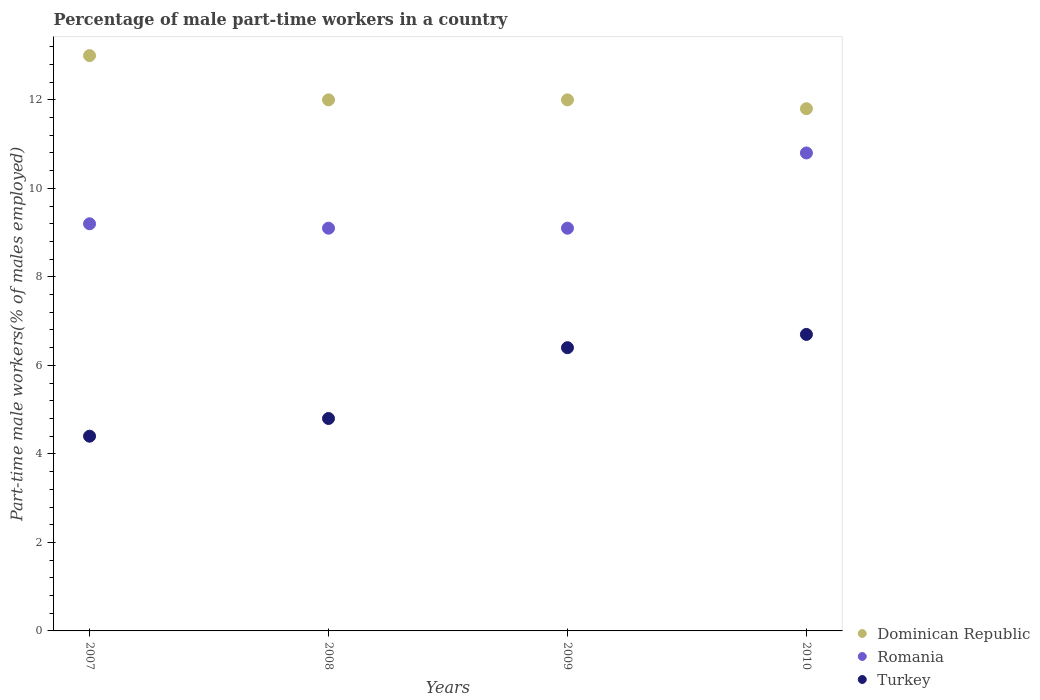How many different coloured dotlines are there?
Make the answer very short. 3. What is the percentage of male part-time workers in Dominican Republic in 2009?
Offer a terse response. 12. Across all years, what is the maximum percentage of male part-time workers in Romania?
Make the answer very short. 10.8. Across all years, what is the minimum percentage of male part-time workers in Romania?
Offer a terse response. 9.1. In which year was the percentage of male part-time workers in Romania maximum?
Make the answer very short. 2010. In which year was the percentage of male part-time workers in Romania minimum?
Ensure brevity in your answer.  2008. What is the total percentage of male part-time workers in Romania in the graph?
Provide a short and direct response. 38.2. What is the difference between the percentage of male part-time workers in Turkey in 2008 and that in 2010?
Your answer should be compact. -1.9. What is the difference between the percentage of male part-time workers in Romania in 2009 and the percentage of male part-time workers in Turkey in 2010?
Your answer should be compact. 2.4. What is the average percentage of male part-time workers in Turkey per year?
Provide a succinct answer. 5.58. In the year 2008, what is the difference between the percentage of male part-time workers in Turkey and percentage of male part-time workers in Dominican Republic?
Offer a very short reply. -7.2. In how many years, is the percentage of male part-time workers in Dominican Republic greater than 11.6 %?
Give a very brief answer. 4. What is the ratio of the percentage of male part-time workers in Dominican Republic in 2007 to that in 2010?
Provide a succinct answer. 1.1. What is the difference between the highest and the second highest percentage of male part-time workers in Romania?
Provide a short and direct response. 1.6. What is the difference between the highest and the lowest percentage of male part-time workers in Turkey?
Provide a succinct answer. 2.3. In how many years, is the percentage of male part-time workers in Romania greater than the average percentage of male part-time workers in Romania taken over all years?
Give a very brief answer. 1. Is the sum of the percentage of male part-time workers in Romania in 2009 and 2010 greater than the maximum percentage of male part-time workers in Dominican Republic across all years?
Keep it short and to the point. Yes. Is it the case that in every year, the sum of the percentage of male part-time workers in Dominican Republic and percentage of male part-time workers in Turkey  is greater than the percentage of male part-time workers in Romania?
Your response must be concise. Yes. Is the percentage of male part-time workers in Romania strictly greater than the percentage of male part-time workers in Turkey over the years?
Offer a terse response. Yes. How many dotlines are there?
Provide a succinct answer. 3. How many years are there in the graph?
Your response must be concise. 4. Where does the legend appear in the graph?
Your response must be concise. Bottom right. What is the title of the graph?
Your answer should be compact. Percentage of male part-time workers in a country. What is the label or title of the Y-axis?
Make the answer very short. Part-time male workers(% of males employed). What is the Part-time male workers(% of males employed) of Romania in 2007?
Provide a succinct answer. 9.2. What is the Part-time male workers(% of males employed) of Turkey in 2007?
Make the answer very short. 4.4. What is the Part-time male workers(% of males employed) in Dominican Republic in 2008?
Keep it short and to the point. 12. What is the Part-time male workers(% of males employed) in Romania in 2008?
Make the answer very short. 9.1. What is the Part-time male workers(% of males employed) of Turkey in 2008?
Your response must be concise. 4.8. What is the Part-time male workers(% of males employed) in Romania in 2009?
Offer a terse response. 9.1. What is the Part-time male workers(% of males employed) of Turkey in 2009?
Offer a terse response. 6.4. What is the Part-time male workers(% of males employed) of Dominican Republic in 2010?
Provide a succinct answer. 11.8. What is the Part-time male workers(% of males employed) in Romania in 2010?
Your answer should be very brief. 10.8. What is the Part-time male workers(% of males employed) in Turkey in 2010?
Offer a very short reply. 6.7. Across all years, what is the maximum Part-time male workers(% of males employed) in Romania?
Provide a succinct answer. 10.8. Across all years, what is the maximum Part-time male workers(% of males employed) of Turkey?
Your response must be concise. 6.7. Across all years, what is the minimum Part-time male workers(% of males employed) in Dominican Republic?
Your response must be concise. 11.8. Across all years, what is the minimum Part-time male workers(% of males employed) of Romania?
Provide a short and direct response. 9.1. Across all years, what is the minimum Part-time male workers(% of males employed) in Turkey?
Offer a very short reply. 4.4. What is the total Part-time male workers(% of males employed) in Dominican Republic in the graph?
Give a very brief answer. 48.8. What is the total Part-time male workers(% of males employed) in Romania in the graph?
Your answer should be compact. 38.2. What is the total Part-time male workers(% of males employed) in Turkey in the graph?
Your response must be concise. 22.3. What is the difference between the Part-time male workers(% of males employed) of Dominican Republic in 2007 and that in 2008?
Provide a short and direct response. 1. What is the difference between the Part-time male workers(% of males employed) of Romania in 2007 and that in 2009?
Keep it short and to the point. 0.1. What is the difference between the Part-time male workers(% of males employed) of Turkey in 2007 and that in 2009?
Your answer should be compact. -2. What is the difference between the Part-time male workers(% of males employed) of Romania in 2007 and that in 2010?
Provide a succinct answer. -1.6. What is the difference between the Part-time male workers(% of males employed) of Turkey in 2007 and that in 2010?
Make the answer very short. -2.3. What is the difference between the Part-time male workers(% of males employed) of Turkey in 2008 and that in 2009?
Offer a terse response. -1.6. What is the difference between the Part-time male workers(% of males employed) in Dominican Republic in 2007 and the Part-time male workers(% of males employed) in Romania in 2009?
Give a very brief answer. 3.9. What is the difference between the Part-time male workers(% of males employed) in Dominican Republic in 2007 and the Part-time male workers(% of males employed) in Turkey in 2009?
Your response must be concise. 6.6. What is the difference between the Part-time male workers(% of males employed) of Romania in 2007 and the Part-time male workers(% of males employed) of Turkey in 2009?
Provide a succinct answer. 2.8. What is the difference between the Part-time male workers(% of males employed) in Dominican Republic in 2007 and the Part-time male workers(% of males employed) in Romania in 2010?
Give a very brief answer. 2.2. What is the difference between the Part-time male workers(% of males employed) of Dominican Republic in 2007 and the Part-time male workers(% of males employed) of Turkey in 2010?
Your answer should be compact. 6.3. What is the difference between the Part-time male workers(% of males employed) of Romania in 2007 and the Part-time male workers(% of males employed) of Turkey in 2010?
Ensure brevity in your answer.  2.5. What is the difference between the Part-time male workers(% of males employed) of Dominican Republic in 2008 and the Part-time male workers(% of males employed) of Turkey in 2009?
Your answer should be compact. 5.6. What is the difference between the Part-time male workers(% of males employed) in Dominican Republic in 2008 and the Part-time male workers(% of males employed) in Romania in 2010?
Offer a terse response. 1.2. What is the difference between the Part-time male workers(% of males employed) of Dominican Republic in 2009 and the Part-time male workers(% of males employed) of Romania in 2010?
Provide a short and direct response. 1.2. What is the difference between the Part-time male workers(% of males employed) of Romania in 2009 and the Part-time male workers(% of males employed) of Turkey in 2010?
Your response must be concise. 2.4. What is the average Part-time male workers(% of males employed) in Romania per year?
Make the answer very short. 9.55. What is the average Part-time male workers(% of males employed) in Turkey per year?
Provide a short and direct response. 5.58. In the year 2007, what is the difference between the Part-time male workers(% of males employed) of Dominican Republic and Part-time male workers(% of males employed) of Romania?
Provide a short and direct response. 3.8. In the year 2007, what is the difference between the Part-time male workers(% of males employed) in Dominican Republic and Part-time male workers(% of males employed) in Turkey?
Ensure brevity in your answer.  8.6. In the year 2008, what is the difference between the Part-time male workers(% of males employed) in Dominican Republic and Part-time male workers(% of males employed) in Romania?
Offer a terse response. 2.9. In the year 2009, what is the difference between the Part-time male workers(% of males employed) in Dominican Republic and Part-time male workers(% of males employed) in Romania?
Ensure brevity in your answer.  2.9. In the year 2009, what is the difference between the Part-time male workers(% of males employed) in Dominican Republic and Part-time male workers(% of males employed) in Turkey?
Keep it short and to the point. 5.6. In the year 2010, what is the difference between the Part-time male workers(% of males employed) in Dominican Republic and Part-time male workers(% of males employed) in Turkey?
Offer a terse response. 5.1. What is the ratio of the Part-time male workers(% of males employed) in Dominican Republic in 2007 to that in 2008?
Give a very brief answer. 1.08. What is the ratio of the Part-time male workers(% of males employed) in Romania in 2007 to that in 2008?
Keep it short and to the point. 1.01. What is the ratio of the Part-time male workers(% of males employed) in Turkey in 2007 to that in 2008?
Give a very brief answer. 0.92. What is the ratio of the Part-time male workers(% of males employed) in Romania in 2007 to that in 2009?
Make the answer very short. 1.01. What is the ratio of the Part-time male workers(% of males employed) in Turkey in 2007 to that in 2009?
Keep it short and to the point. 0.69. What is the ratio of the Part-time male workers(% of males employed) of Dominican Republic in 2007 to that in 2010?
Provide a succinct answer. 1.1. What is the ratio of the Part-time male workers(% of males employed) of Romania in 2007 to that in 2010?
Your answer should be very brief. 0.85. What is the ratio of the Part-time male workers(% of males employed) in Turkey in 2007 to that in 2010?
Offer a very short reply. 0.66. What is the ratio of the Part-time male workers(% of males employed) of Romania in 2008 to that in 2009?
Provide a succinct answer. 1. What is the ratio of the Part-time male workers(% of males employed) in Turkey in 2008 to that in 2009?
Offer a terse response. 0.75. What is the ratio of the Part-time male workers(% of males employed) in Dominican Republic in 2008 to that in 2010?
Provide a succinct answer. 1.02. What is the ratio of the Part-time male workers(% of males employed) of Romania in 2008 to that in 2010?
Provide a succinct answer. 0.84. What is the ratio of the Part-time male workers(% of males employed) in Turkey in 2008 to that in 2010?
Your answer should be very brief. 0.72. What is the ratio of the Part-time male workers(% of males employed) of Dominican Republic in 2009 to that in 2010?
Ensure brevity in your answer.  1.02. What is the ratio of the Part-time male workers(% of males employed) in Romania in 2009 to that in 2010?
Offer a very short reply. 0.84. What is the ratio of the Part-time male workers(% of males employed) in Turkey in 2009 to that in 2010?
Provide a short and direct response. 0.96. What is the difference between the highest and the second highest Part-time male workers(% of males employed) of Romania?
Your response must be concise. 1.6. What is the difference between the highest and the lowest Part-time male workers(% of males employed) of Dominican Republic?
Your response must be concise. 1.2. 